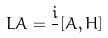<formula> <loc_0><loc_0><loc_500><loc_500>L A = \frac { i } { } [ A , H ]</formula> 